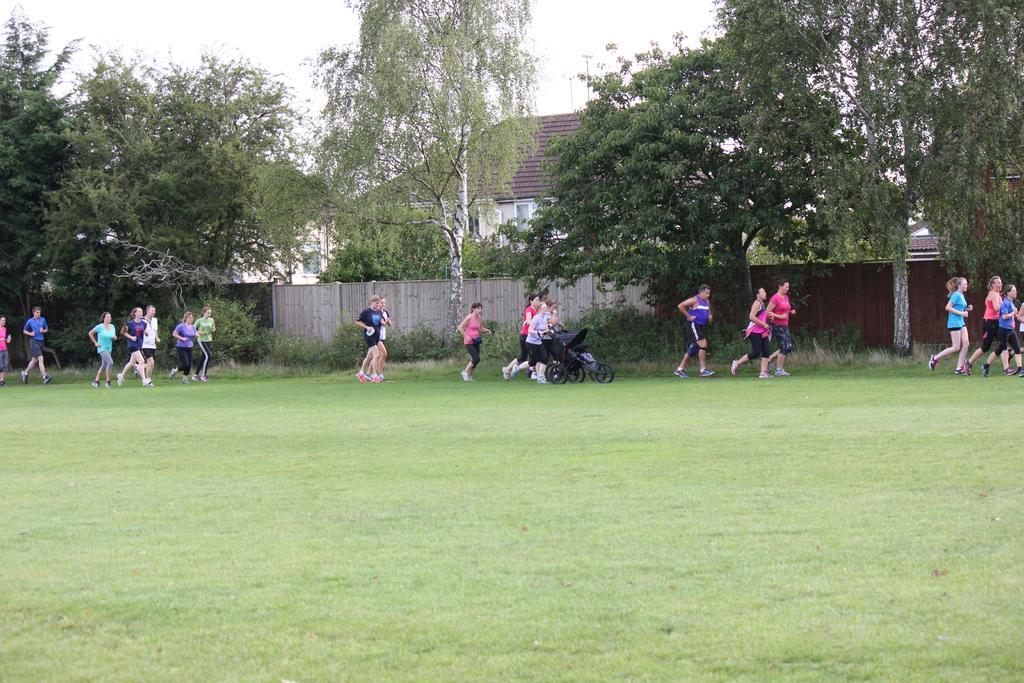Please provide a concise description of this image. In the foreground of the picture we can see grass. In the middle of the picture there are plants, trees, wall, buildings and people walking through the ground. At the top there is sky. 